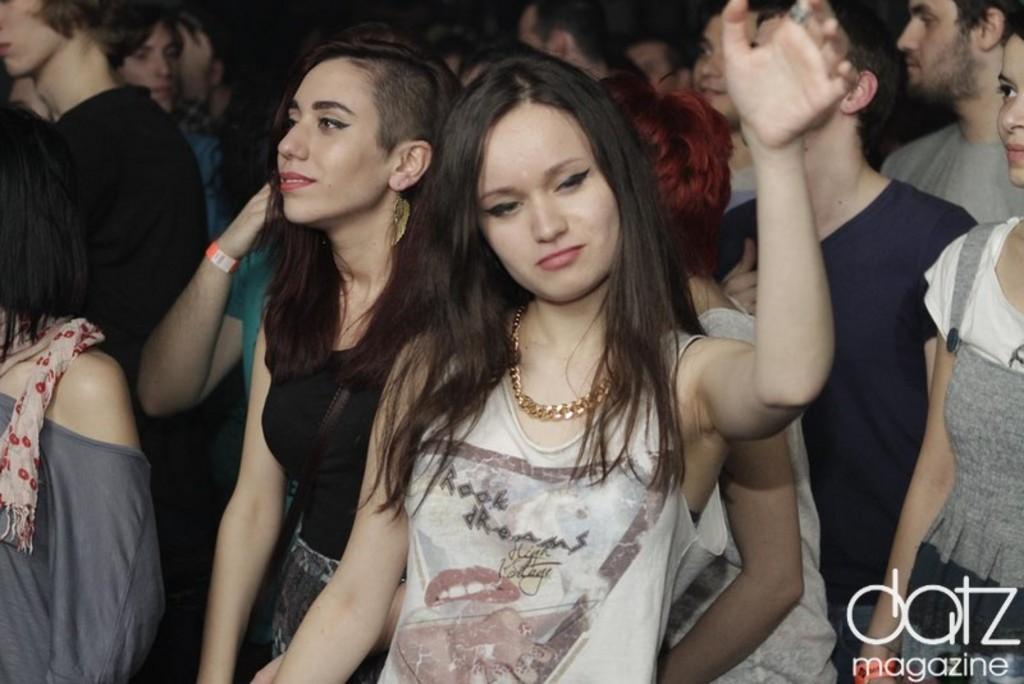How would you summarize this image in a sentence or two? In this image there are people. At the bottom right side of the image there is a watermark. 